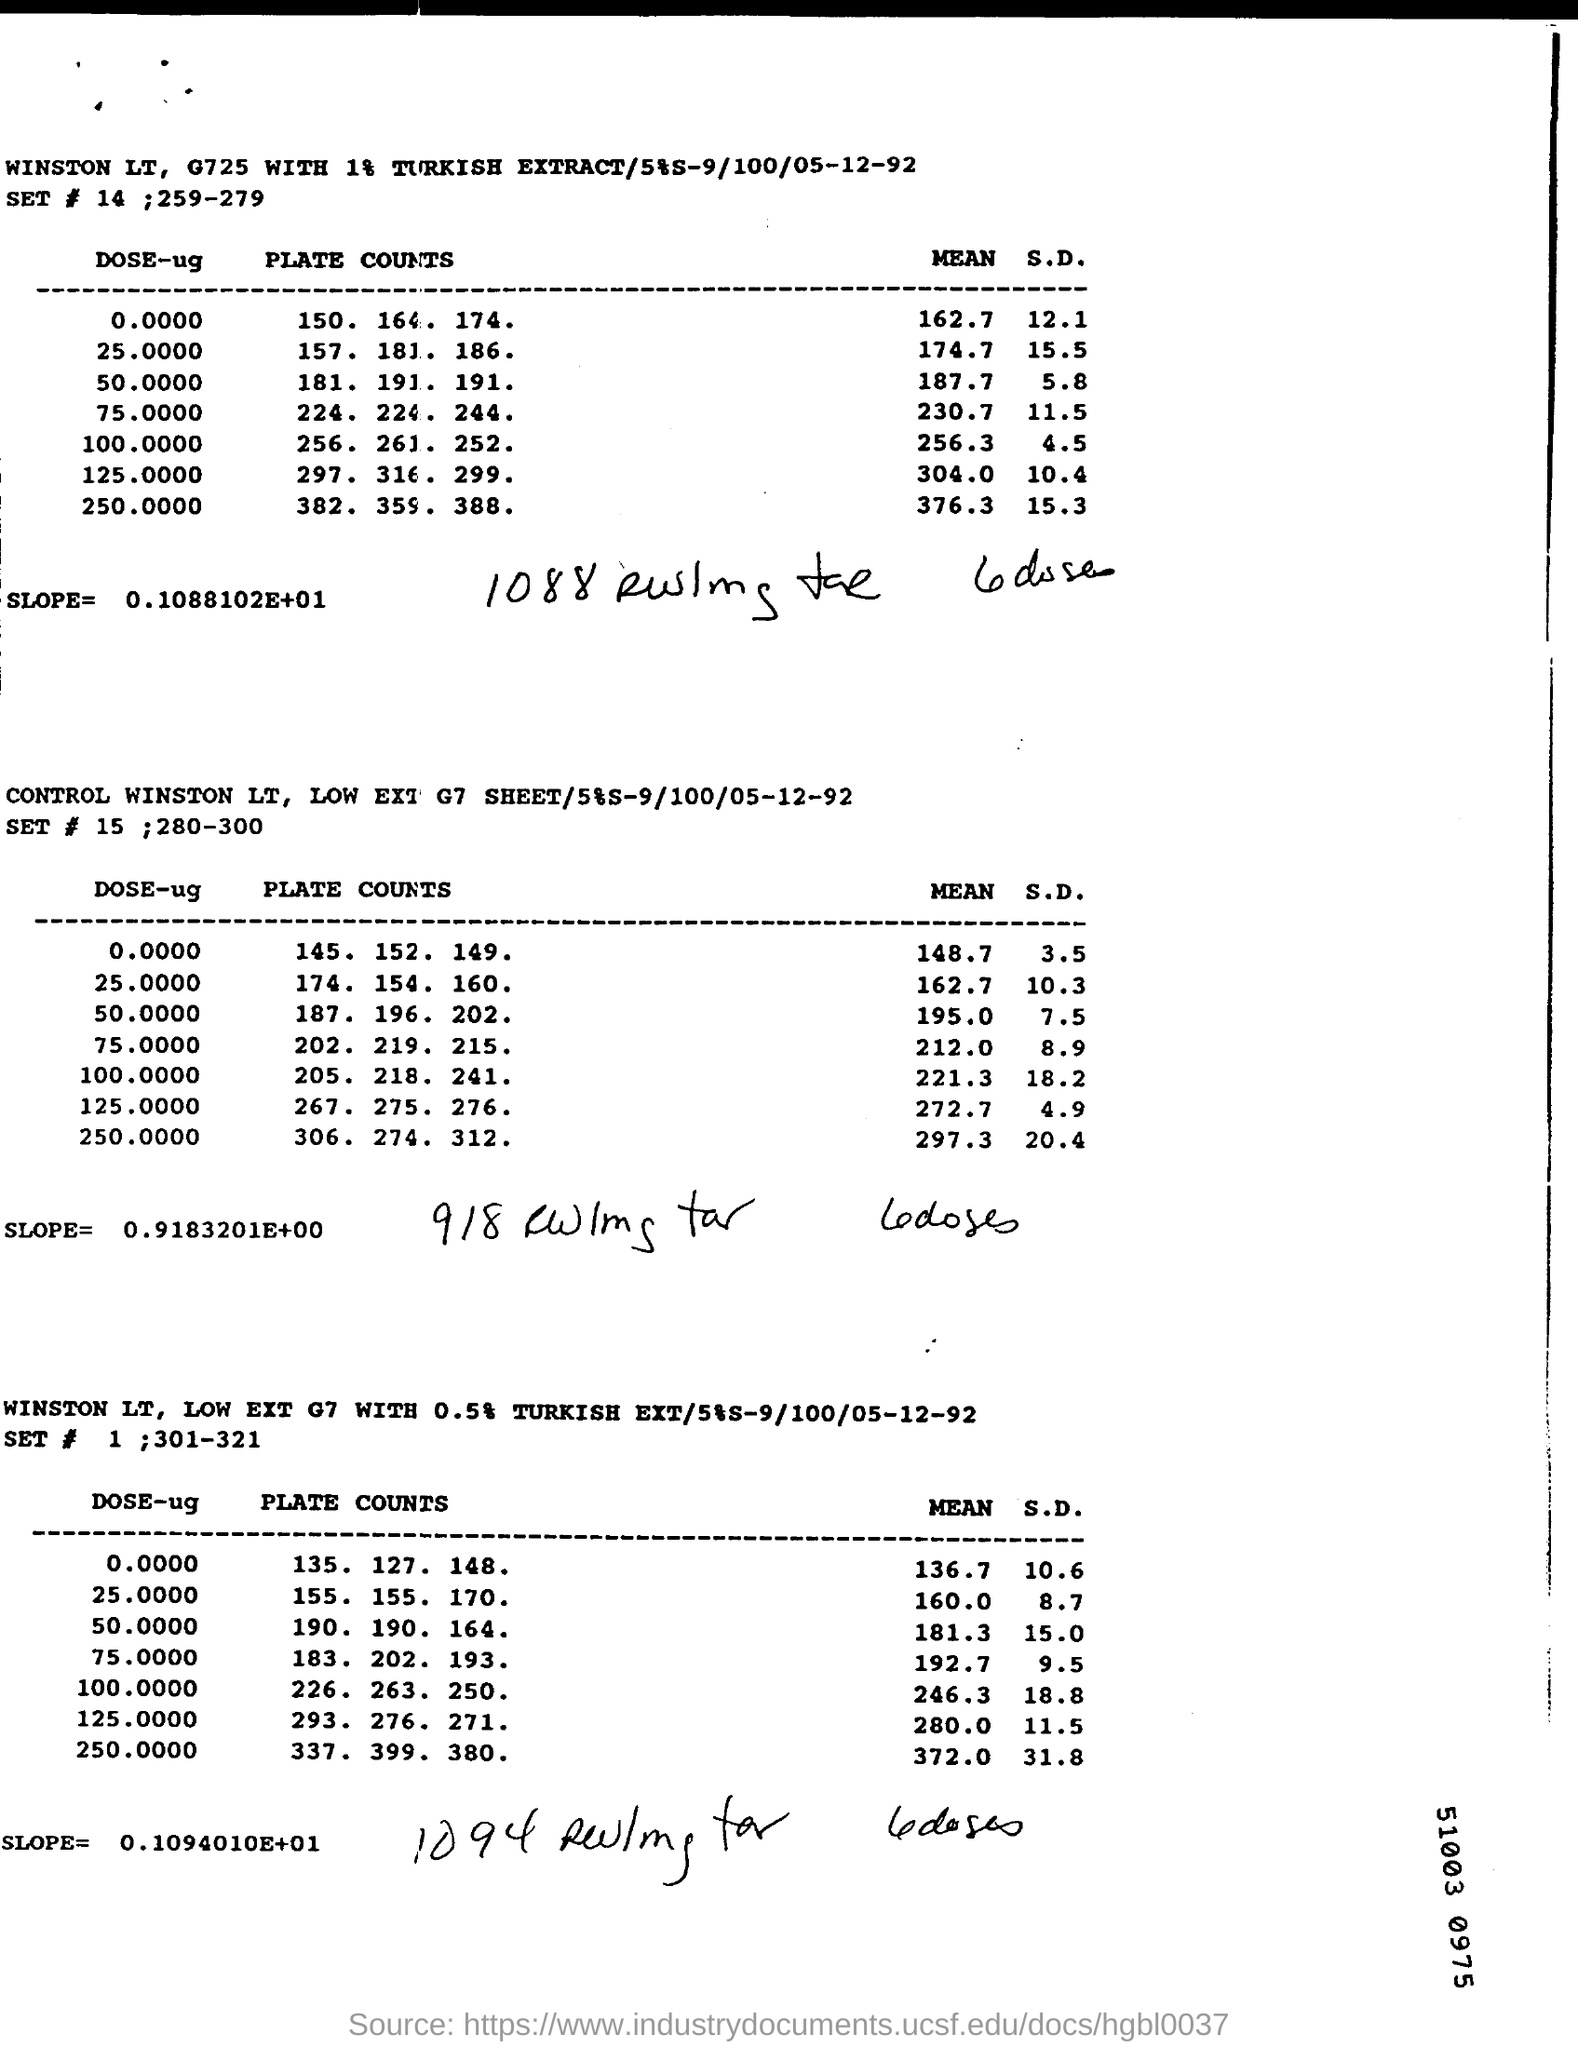What is the slope mentioned in the first table?
Your answer should be very brief. 0.1088102E+01. What is the date mentioned in the second table?
Offer a terse response. 05-12-92. What is the S.D. mentioned in the DOSE-ug 0.0000 in the third table?
Make the answer very short. 10.6. 